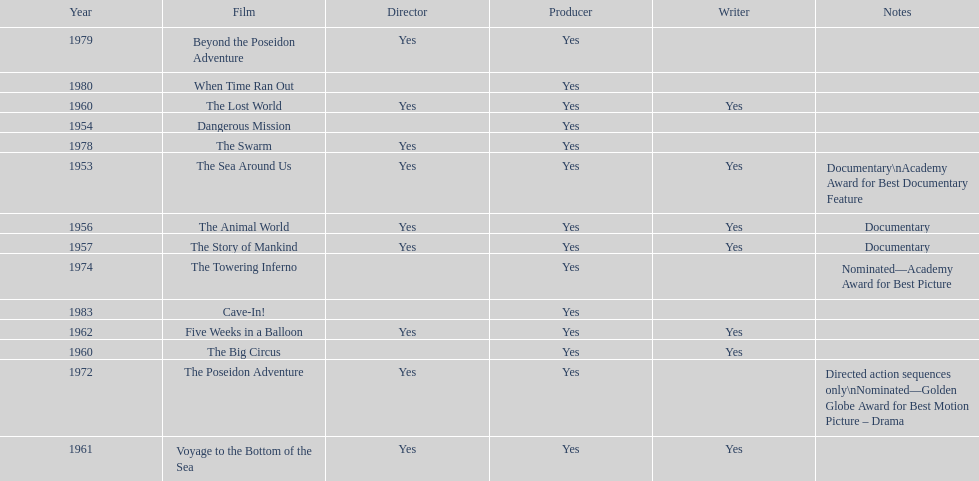How many films did irwin allen direct, produce and write? 6. 